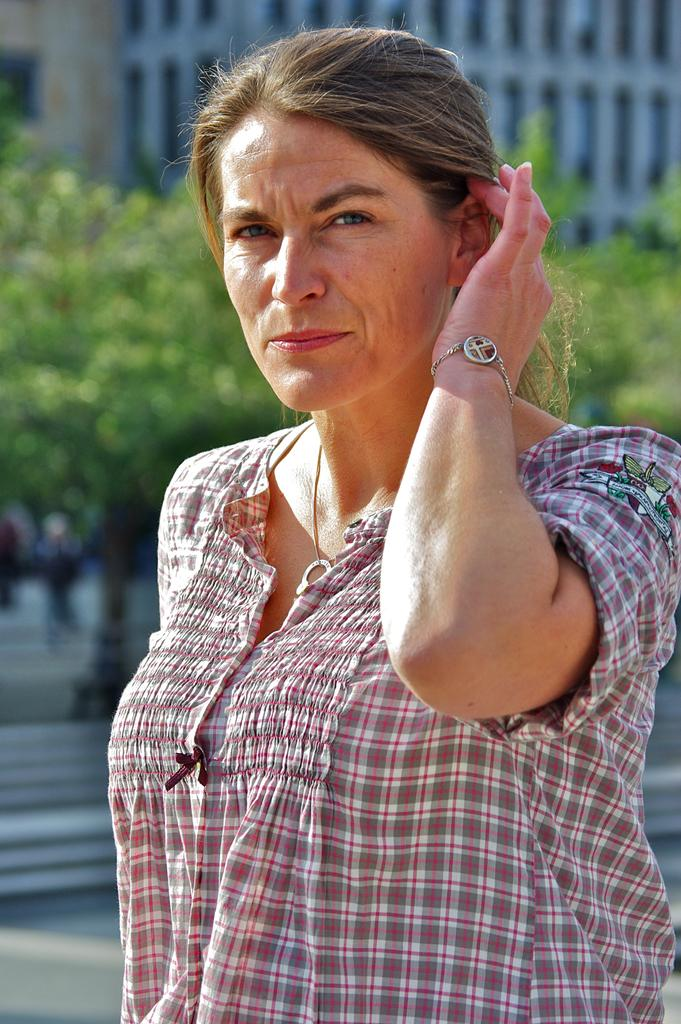Who is the main subject in the image? There is a woman in the image. What is the woman doing in the image? The woman is posing for a photo. Can you describe the background of the image? The background of the woman is blurred. What type of arch can be seen in the background of the image? There is no arch present in the image; the background is blurred. How many fans are visible in the image? There are no fans visible in the image. 